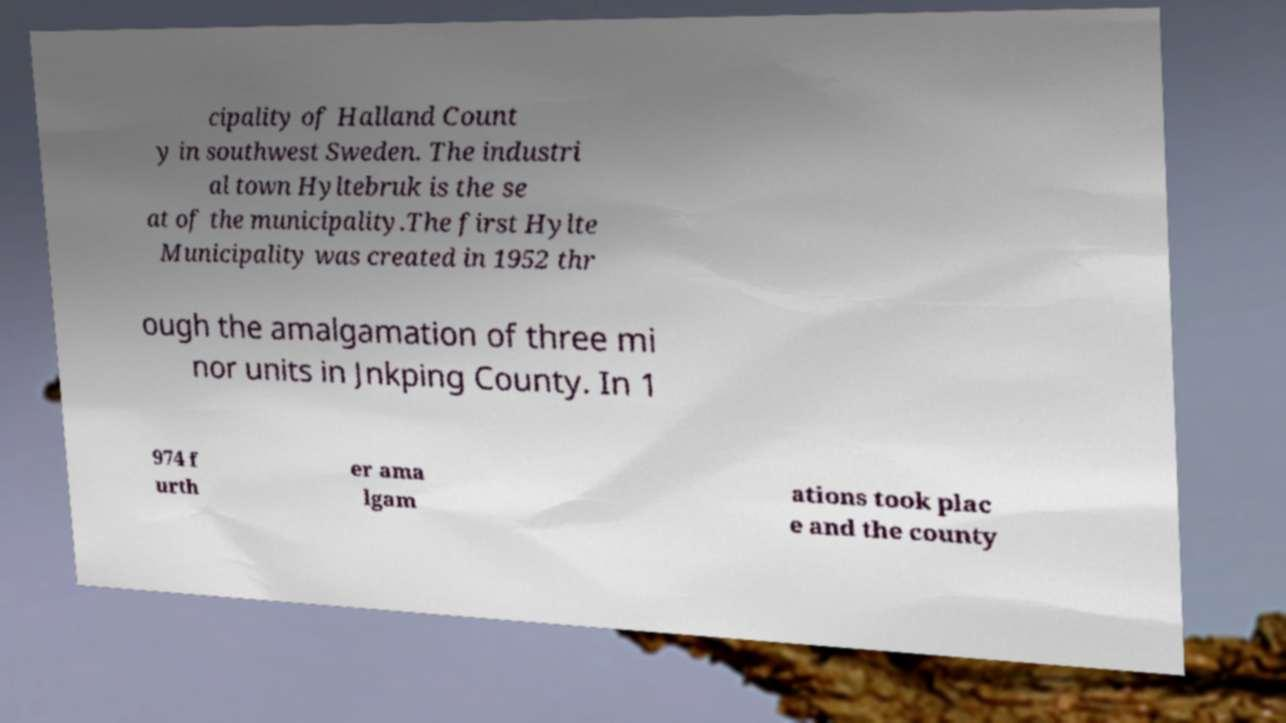Could you assist in decoding the text presented in this image and type it out clearly? cipality of Halland Count y in southwest Sweden. The industri al town Hyltebruk is the se at of the municipality.The first Hylte Municipality was created in 1952 thr ough the amalgamation of three mi nor units in Jnkping County. In 1 974 f urth er ama lgam ations took plac e and the county 